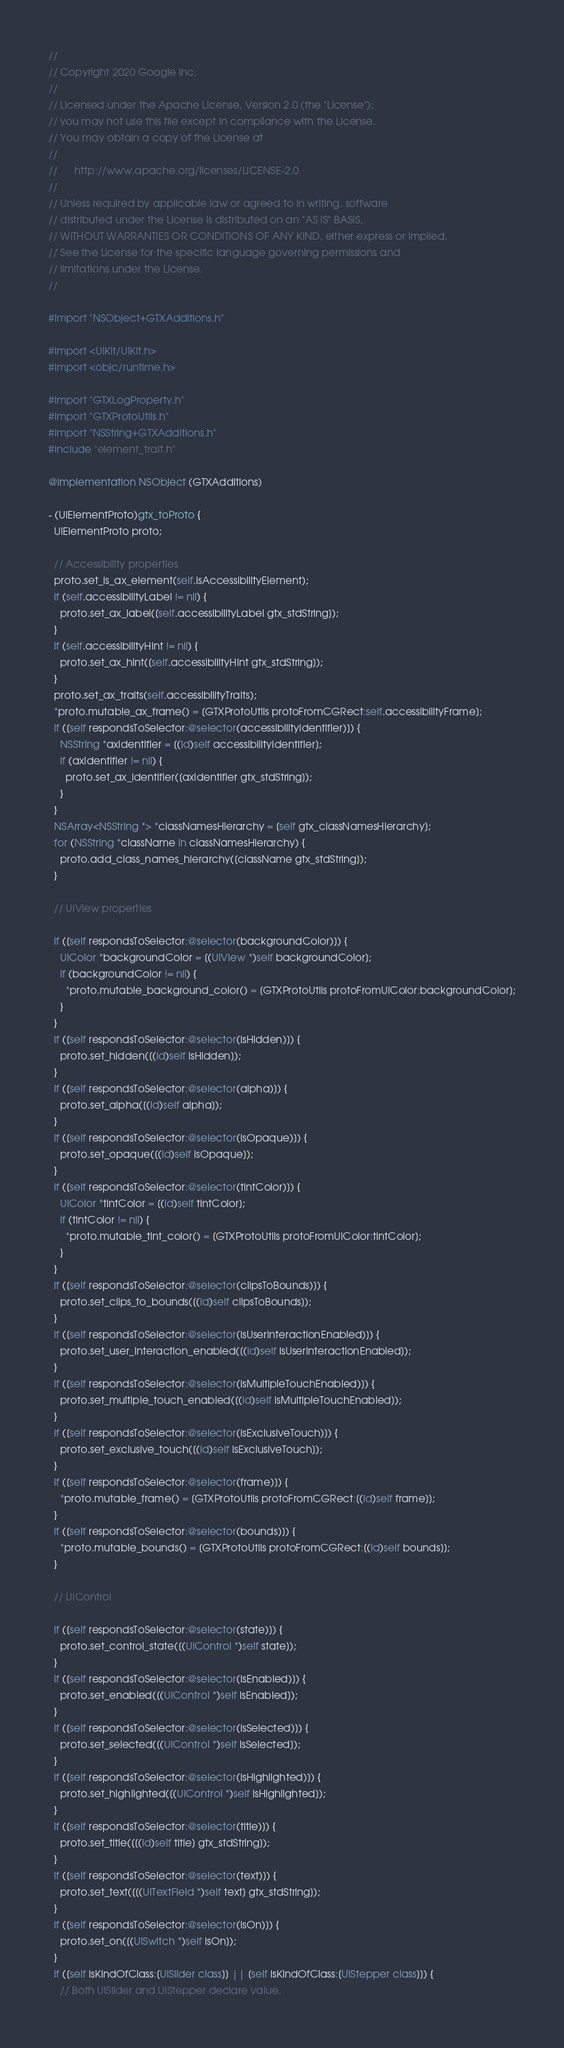<code> <loc_0><loc_0><loc_500><loc_500><_ObjectiveC_>//
// Copyright 2020 Google Inc.
//
// Licensed under the Apache License, Version 2.0 (the "License");
// you may not use this file except in compliance with the License.
// You may obtain a copy of the License at
//
//      http://www.apache.org/licenses/LICENSE-2.0
//
// Unless required by applicable law or agreed to in writing, software
// distributed under the License is distributed on an "AS IS" BASIS,
// WITHOUT WARRANTIES OR CONDITIONS OF ANY KIND, either express or implied.
// See the License for the specific language governing permissions and
// limitations under the License.
//

#import "NSObject+GTXAdditions.h"

#import <UIKit/UIKit.h>
#import <objc/runtime.h>

#import "GTXLogProperty.h"
#import "GTXProtoUtils.h"
#import "NSString+GTXAdditions.h"
#include "element_trait.h"

@implementation NSObject (GTXAdditions)

- (UIElementProto)gtx_toProto {
  UIElementProto proto;

  // Accessibility properties
  proto.set_is_ax_element(self.isAccessibilityElement);
  if (self.accessibilityLabel != nil) {
    proto.set_ax_label([self.accessibilityLabel gtx_stdString]);
  }
  if (self.accessibilityHint != nil) {
    proto.set_ax_hint([self.accessibilityHint gtx_stdString]);
  }
  proto.set_ax_traits(self.accessibilityTraits);
  *proto.mutable_ax_frame() = [GTXProtoUtils protoFromCGRect:self.accessibilityFrame];
  if ([self respondsToSelector:@selector(accessibilityIdentifier)]) {
    NSString *axIdentifier = [(id)self accessibilityIdentifier];
    if (axIdentifier != nil) {
      proto.set_ax_identifier([axIdentifier gtx_stdString]);
    }
  }
  NSArray<NSString *> *classNamesHierarchy = [self gtx_classNamesHierarchy];
  for (NSString *className in classNamesHierarchy) {
    proto.add_class_names_hierarchy([className gtx_stdString]);
  }

  // UIView properties

  if ([self respondsToSelector:@selector(backgroundColor)]) {
    UIColor *backgroundColor = [(UIView *)self backgroundColor];
    if (backgroundColor != nil) {
      *proto.mutable_background_color() = [GTXProtoUtils protoFromUIColor:backgroundColor];
    }
  }
  if ([self respondsToSelector:@selector(isHidden)]) {
    proto.set_hidden([(id)self isHidden]);
  }
  if ([self respondsToSelector:@selector(alpha)]) {
    proto.set_alpha([(id)self alpha]);
  }
  if ([self respondsToSelector:@selector(isOpaque)]) {
    proto.set_opaque([(id)self isOpaque]);
  }
  if ([self respondsToSelector:@selector(tintColor)]) {
    UIColor *tintColor = [(id)self tintColor];
    if (tintColor != nil) {
      *proto.mutable_tint_color() = [GTXProtoUtils protoFromUIColor:tintColor];
    }
  }
  if ([self respondsToSelector:@selector(clipsToBounds)]) {
    proto.set_clips_to_bounds([(id)self clipsToBounds]);
  }
  if ([self respondsToSelector:@selector(isUserInteractionEnabled)]) {
    proto.set_user_interaction_enabled([(id)self isUserInteractionEnabled]);
  }
  if ([self respondsToSelector:@selector(isMultipleTouchEnabled)]) {
    proto.set_multiple_touch_enabled([(id)self isMultipleTouchEnabled]);
  }
  if ([self respondsToSelector:@selector(isExclusiveTouch)]) {
    proto.set_exclusive_touch([(id)self isExclusiveTouch]);
  }
  if ([self respondsToSelector:@selector(frame)]) {
    *proto.mutable_frame() = [GTXProtoUtils protoFromCGRect:[(id)self frame]];
  }
  if ([self respondsToSelector:@selector(bounds)]) {
    *proto.mutable_bounds() = [GTXProtoUtils protoFromCGRect:[(id)self bounds]];
  }

  // UIControl

  if ([self respondsToSelector:@selector(state)]) {
    proto.set_control_state([(UIControl *)self state]);
  }
  if ([self respondsToSelector:@selector(isEnabled)]) {
    proto.set_enabled([(UIControl *)self isEnabled]);
  }
  if ([self respondsToSelector:@selector(isSelected)]) {
    proto.set_selected([(UIControl *)self isSelected]);
  }
  if ([self respondsToSelector:@selector(isHighlighted)]) {
    proto.set_highlighted([(UIControl *)self isHighlighted]);
  }
  if ([self respondsToSelector:@selector(title)]) {
    proto.set_title([[(id)self title] gtx_stdString]);
  }
  if ([self respondsToSelector:@selector(text)]) {
    proto.set_text([[(UITextField *)self text] gtx_stdString]);
  }
  if ([self respondsToSelector:@selector(isOn)]) {
    proto.set_on([(UISwitch *)self isOn]);
  }
  if ([self isKindOfClass:[UISlider class]] || [self isKindOfClass:[UIStepper class]]) {
    // Both UISlider and UIStepper declare value.</code> 